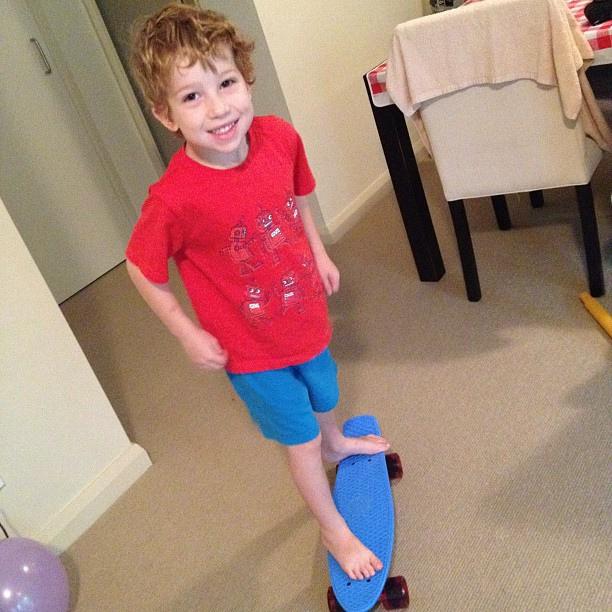About how old is this child?
Keep it brief. 7. What is the of the boy's shorts?
Short answer required. Blue. What is the boy standing on?
Give a very brief answer. Skateboard. 